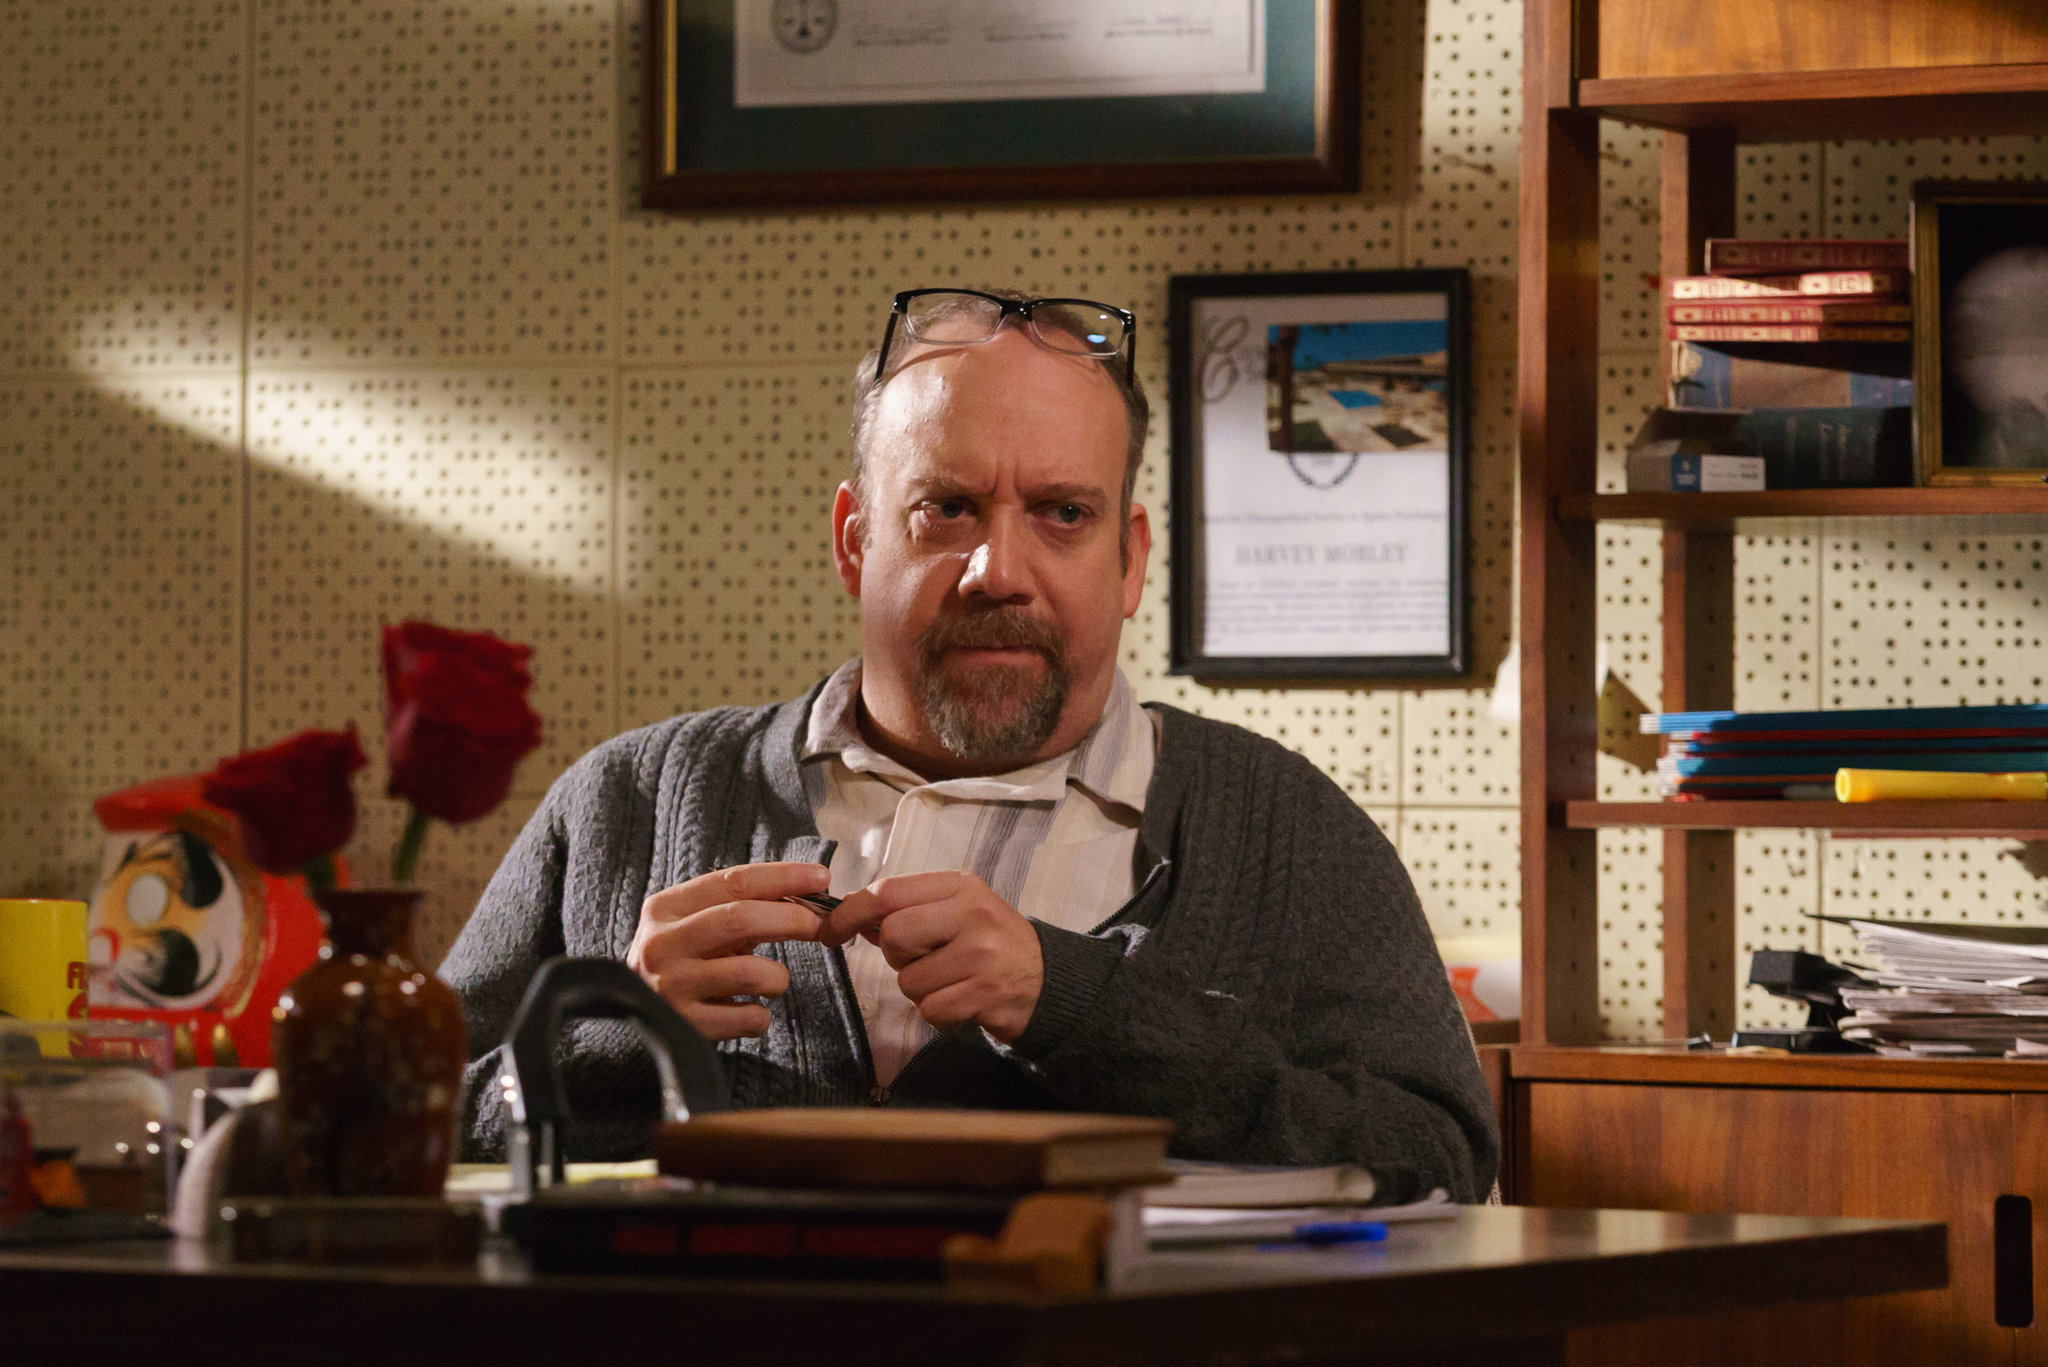Write a detailed description of the given image. The image depicts a middle-aged man with a steady, contemplative gaze sitting at a cluttered desk surrounded by various objects that suggest a personal workspace. He is dressed in a cozy gray cardigan over a beige shirt with the sleeves slightly rolled up. His hands are preoccupied as he holds a small object near a cup, possibly in the middle of a routine task or a moment of contemplation.

The desk is filled with books, scattered papers, and personal items such as a quirky Donald Duck tin container and a flower vase with a single rose, adding a touch of personality and color to the environment. Decorative items and frames in the background hint at a lived-in and personalized office space. The setting is warmly lit, casting a homely and inviting ambiance over a scene that appears to be a blend of personal and professional life. 